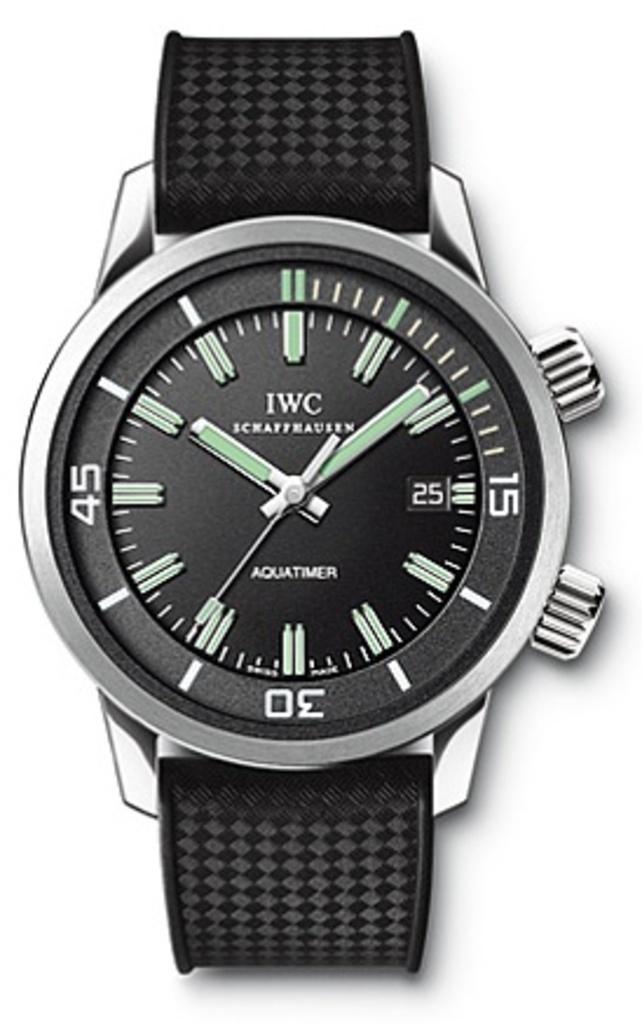What brand is this?
Provide a short and direct response. Iwc. What is this watch called?
Give a very brief answer. Iwc. 